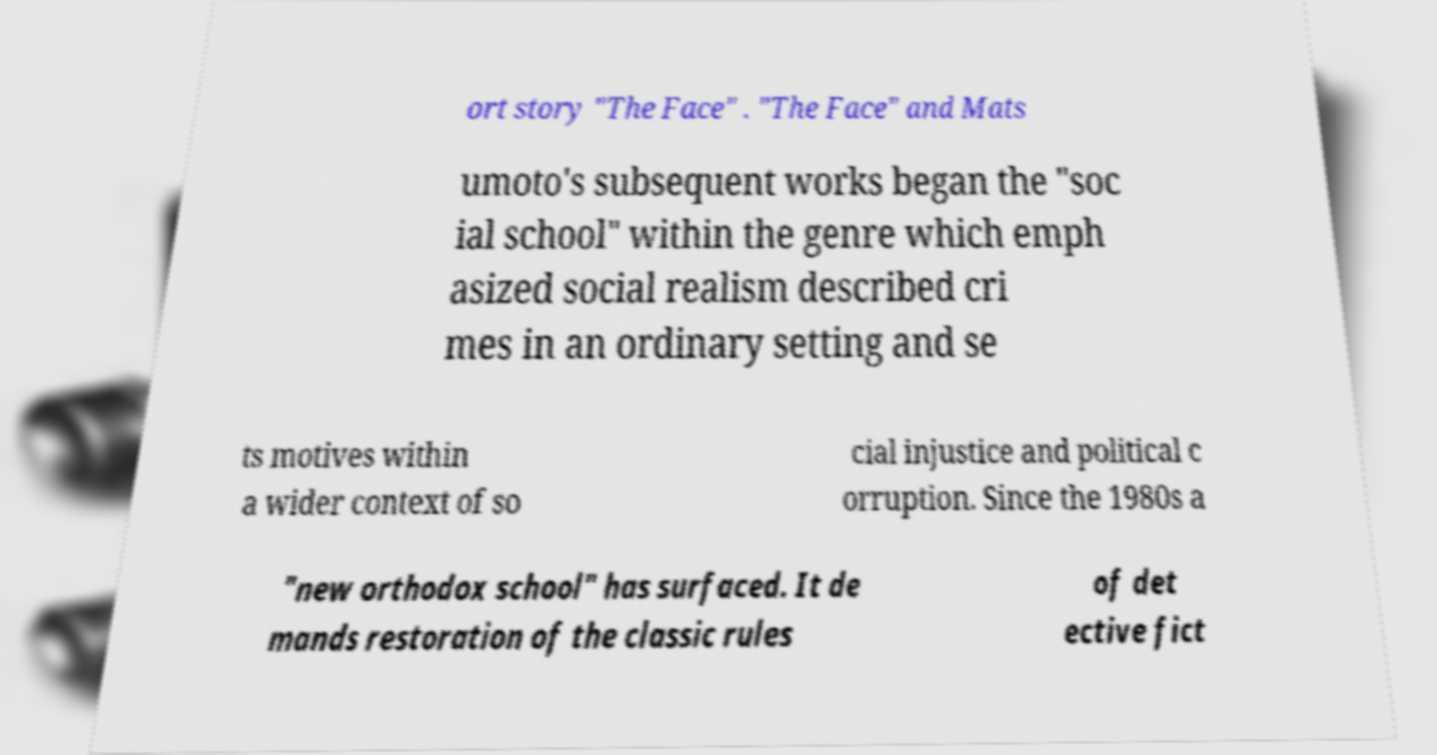Could you assist in decoding the text presented in this image and type it out clearly? ort story "The Face" . "The Face" and Mats umoto's subsequent works began the "soc ial school" within the genre which emph asized social realism described cri mes in an ordinary setting and se ts motives within a wider context of so cial injustice and political c orruption. Since the 1980s a "new orthodox school" has surfaced. It de mands restoration of the classic rules of det ective fict 